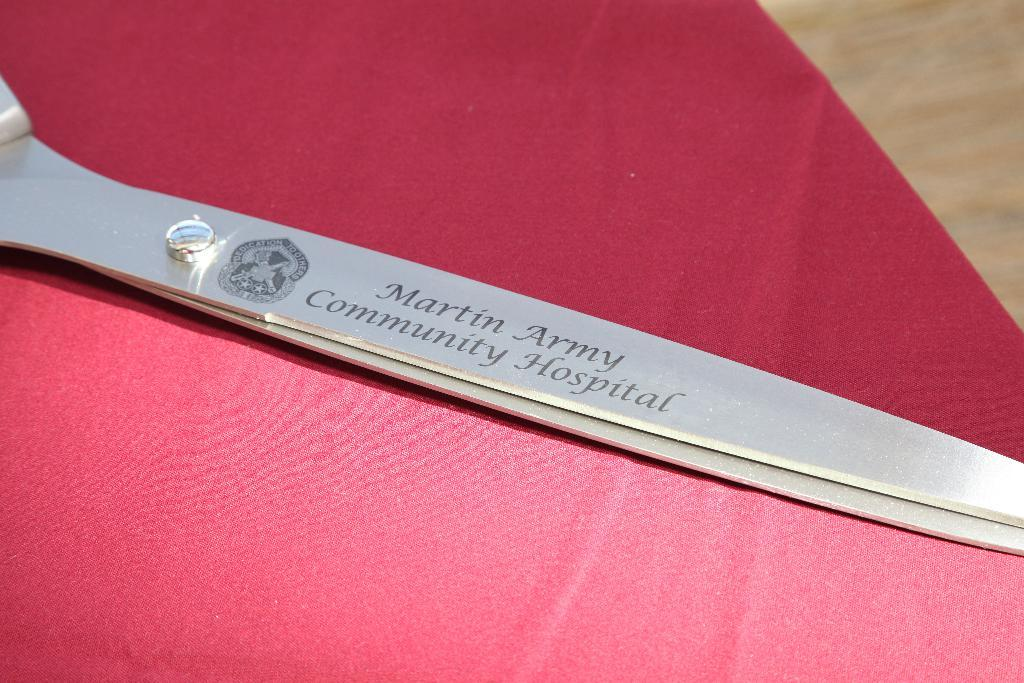What object is present in the image that is used for cutting? There is a scissor in the image that is used for cutting. What is the color of the cloth that the scissor is placed on? The scissor is on a red color cloth. Where is the red color cloth located in the image? The red color cloth is on the floor. What additional features can be found on the scissor? There is text and an image on the scissor. What type of wood is the robin sitting on in the image? There is no robin or wood present in the image; it features a scissor on a red color cloth. 